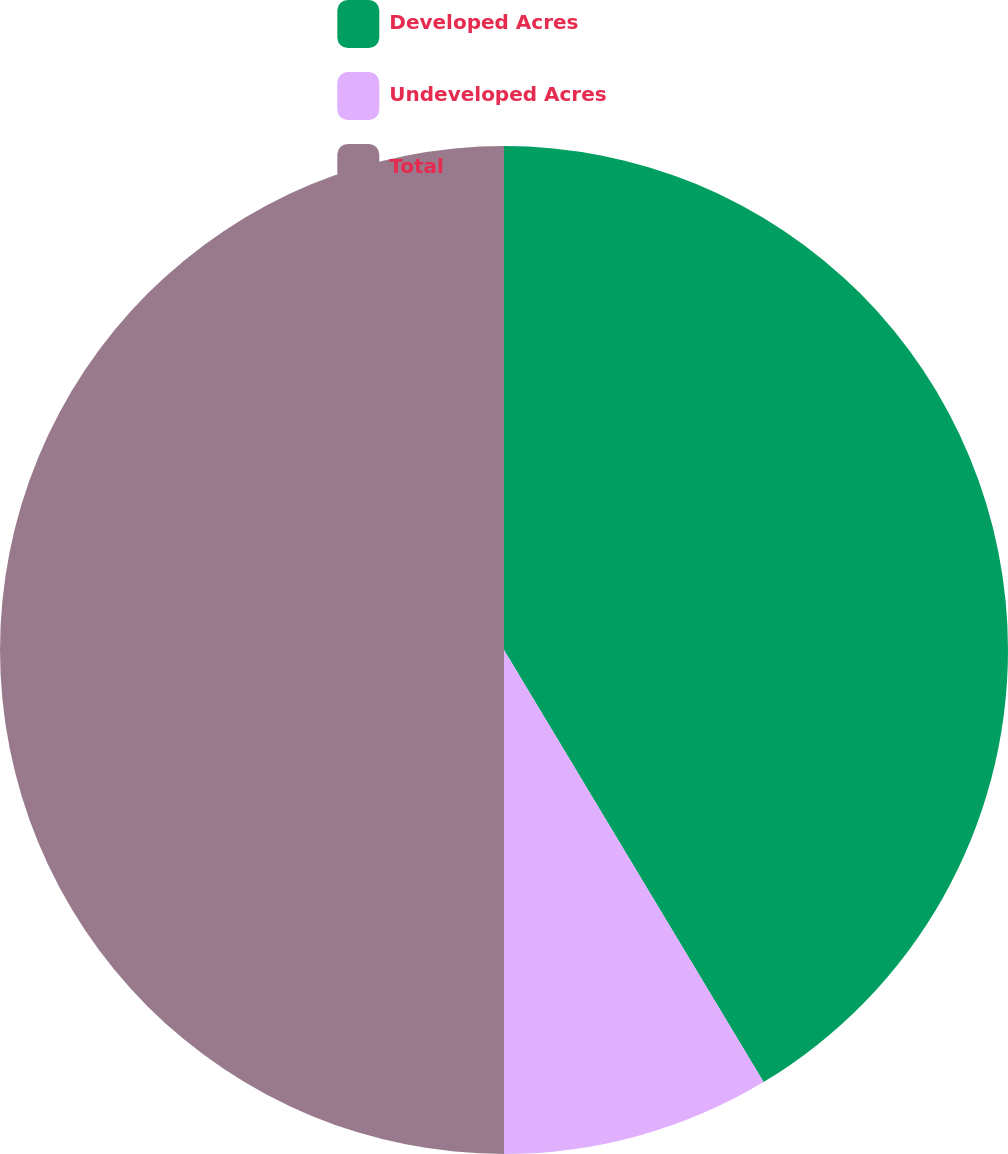Convert chart. <chart><loc_0><loc_0><loc_500><loc_500><pie_chart><fcel>Developed Acres<fcel>Undeveloped Acres<fcel>Total<nl><fcel>41.39%<fcel>8.61%<fcel>50.0%<nl></chart> 